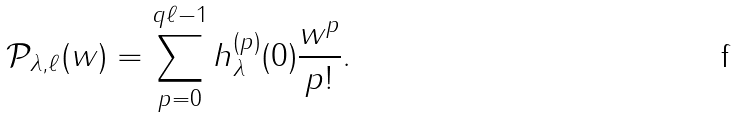Convert formula to latex. <formula><loc_0><loc_0><loc_500><loc_500>\mathcal { P } _ { \lambda , \ell } ( w ) = \sum _ { p = 0 } ^ { q \ell - 1 } h _ { \lambda } ^ { ( p ) } ( 0 ) \frac { w ^ { p } } { p ! } .</formula> 